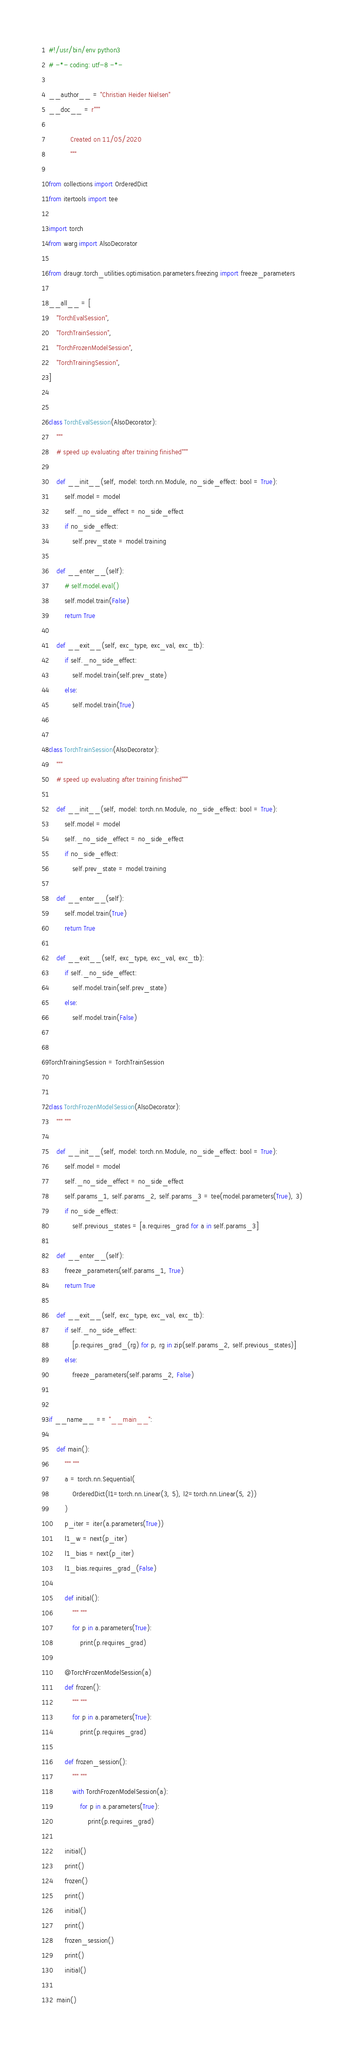<code> <loc_0><loc_0><loc_500><loc_500><_Python_>#!/usr/bin/env python3
# -*- coding: utf-8 -*-

__author__ = "Christian Heider Nielsen"
__doc__ = r"""

           Created on 11/05/2020
           """

from collections import OrderedDict
from itertools import tee

import torch
from warg import AlsoDecorator

from draugr.torch_utilities.optimisation.parameters.freezing import freeze_parameters

__all__ = [
    "TorchEvalSession",
    "TorchTrainSession",
    "TorchFrozenModelSession",
    "TorchTrainingSession",
]


class TorchEvalSession(AlsoDecorator):
    """
    # speed up evaluating after training finished"""

    def __init__(self, model: torch.nn.Module, no_side_effect: bool = True):
        self.model = model
        self._no_side_effect = no_side_effect
        if no_side_effect:
            self.prev_state = model.training

    def __enter__(self):
        # self.model.eval()
        self.model.train(False)
        return True

    def __exit__(self, exc_type, exc_val, exc_tb):
        if self._no_side_effect:
            self.model.train(self.prev_state)
        else:
            self.model.train(True)


class TorchTrainSession(AlsoDecorator):
    """
    # speed up evaluating after training finished"""

    def __init__(self, model: torch.nn.Module, no_side_effect: bool = True):
        self.model = model
        self._no_side_effect = no_side_effect
        if no_side_effect:
            self.prev_state = model.training

    def __enter__(self):
        self.model.train(True)
        return True

    def __exit__(self, exc_type, exc_val, exc_tb):
        if self._no_side_effect:
            self.model.train(self.prev_state)
        else:
            self.model.train(False)


TorchTrainingSession = TorchTrainSession


class TorchFrozenModelSession(AlsoDecorator):
    """ """

    def __init__(self, model: torch.nn.Module, no_side_effect: bool = True):
        self.model = model
        self._no_side_effect = no_side_effect
        self.params_1, self.params_2, self.params_3 = tee(model.parameters(True), 3)
        if no_side_effect:
            self.previous_states = [a.requires_grad for a in self.params_3]

    def __enter__(self):
        freeze_parameters(self.params_1, True)
        return True

    def __exit__(self, exc_type, exc_val, exc_tb):
        if self._no_side_effect:
            [p.requires_grad_(rg) for p, rg in zip(self.params_2, self.previous_states)]
        else:
            freeze_parameters(self.params_2, False)


if __name__ == "__main__":

    def main():
        """ """
        a = torch.nn.Sequential(
            OrderedDict(l1=torch.nn.Linear(3, 5), l2=torch.nn.Linear(5, 2))
        )
        p_iter = iter(a.parameters(True))
        l1_w = next(p_iter)
        l1_bias = next(p_iter)
        l1_bias.requires_grad_(False)

        def initial():
            """ """
            for p in a.parameters(True):
                print(p.requires_grad)

        @TorchFrozenModelSession(a)
        def frozen():
            """ """
            for p in a.parameters(True):
                print(p.requires_grad)

        def frozen_session():
            """ """
            with TorchFrozenModelSession(a):
                for p in a.parameters(True):
                    print(p.requires_grad)

        initial()
        print()
        frozen()
        print()
        initial()
        print()
        frozen_session()
        print()
        initial()

    main()
</code> 